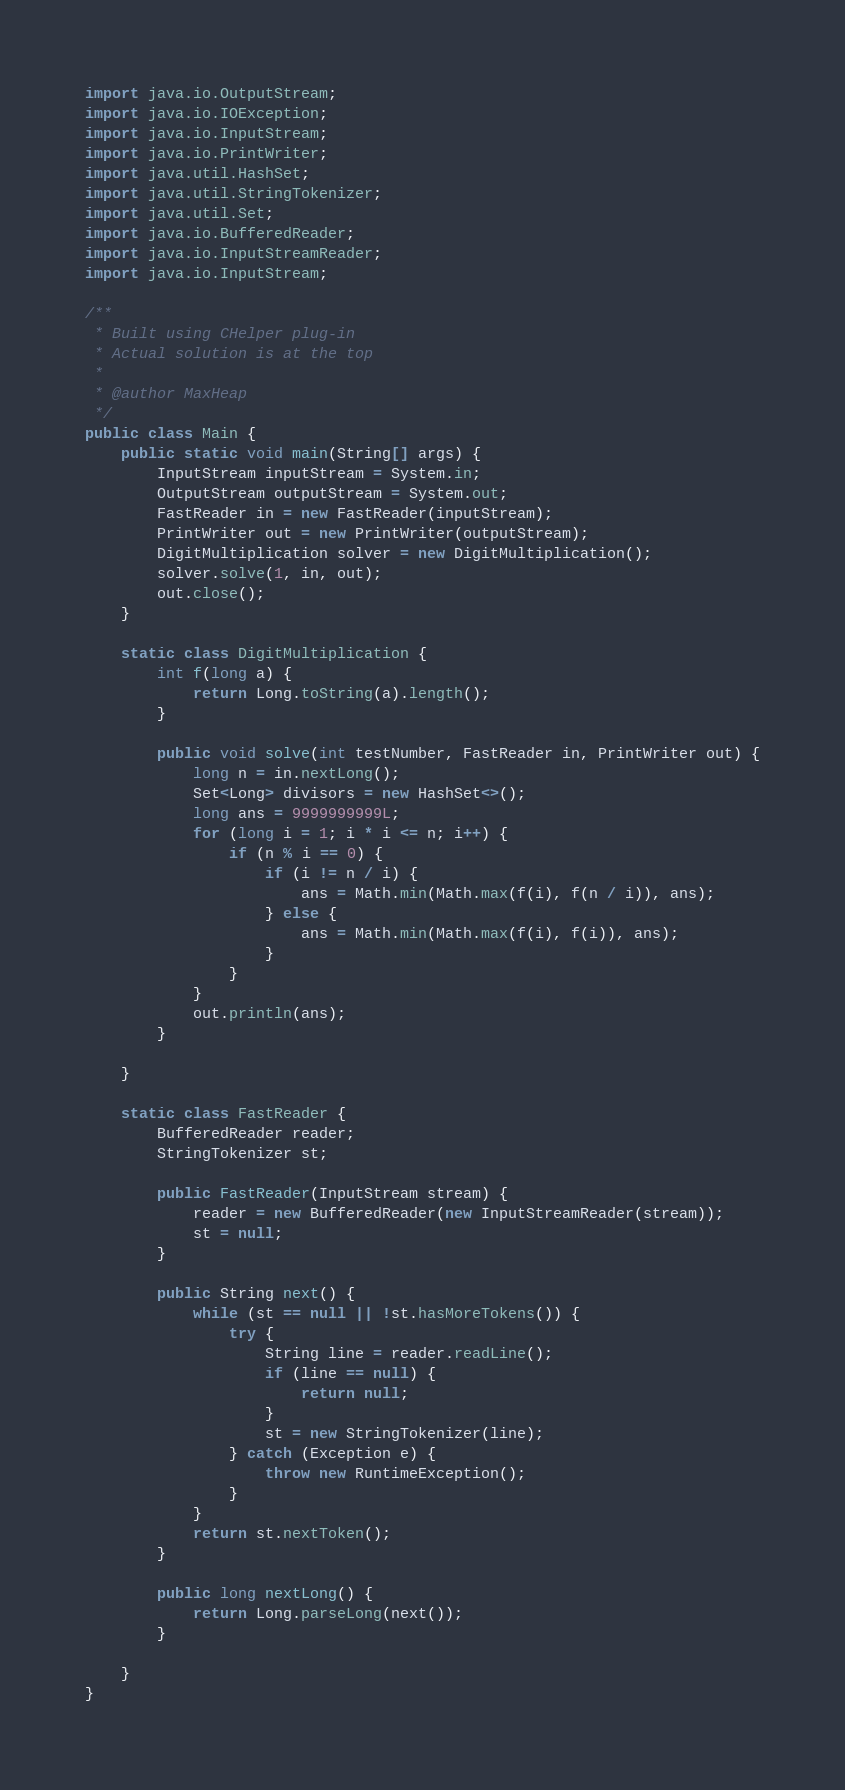Convert code to text. <code><loc_0><loc_0><loc_500><loc_500><_Java_>import java.io.OutputStream;
import java.io.IOException;
import java.io.InputStream;
import java.io.PrintWriter;
import java.util.HashSet;
import java.util.StringTokenizer;
import java.util.Set;
import java.io.BufferedReader;
import java.io.InputStreamReader;
import java.io.InputStream;

/**
 * Built using CHelper plug-in
 * Actual solution is at the top
 *
 * @author MaxHeap
 */
public class Main {
    public static void main(String[] args) {
        InputStream inputStream = System.in;
        OutputStream outputStream = System.out;
        FastReader in = new FastReader(inputStream);
        PrintWriter out = new PrintWriter(outputStream);
        DigitMultiplication solver = new DigitMultiplication();
        solver.solve(1, in, out);
        out.close();
    }

    static class DigitMultiplication {
        int f(long a) {
            return Long.toString(a).length();
        }

        public void solve(int testNumber, FastReader in, PrintWriter out) {
            long n = in.nextLong();
            Set<Long> divisors = new HashSet<>();
            long ans = 9999999999L;
            for (long i = 1; i * i <= n; i++) {
                if (n % i == 0) {
                    if (i != n / i) {
                        ans = Math.min(Math.max(f(i), f(n / i)), ans);
                    } else {
                        ans = Math.min(Math.max(f(i), f(i)), ans);
                    }
                }
            }
            out.println(ans);
        }

    }

    static class FastReader {
        BufferedReader reader;
        StringTokenizer st;

        public FastReader(InputStream stream) {
            reader = new BufferedReader(new InputStreamReader(stream));
            st = null;
        }

        public String next() {
            while (st == null || !st.hasMoreTokens()) {
                try {
                    String line = reader.readLine();
                    if (line == null) {
                        return null;
                    }
                    st = new StringTokenizer(line);
                } catch (Exception e) {
                    throw new RuntimeException();
                }
            }
            return st.nextToken();
        }

        public long nextLong() {
            return Long.parseLong(next());
        }

    }
}

</code> 